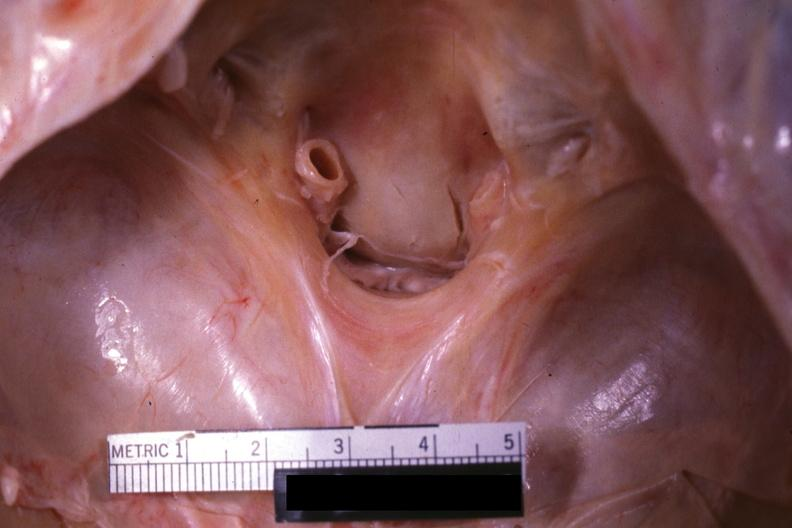what does this image show?
Answer the question using a single word or phrase. Close-up view of foramen magnum 